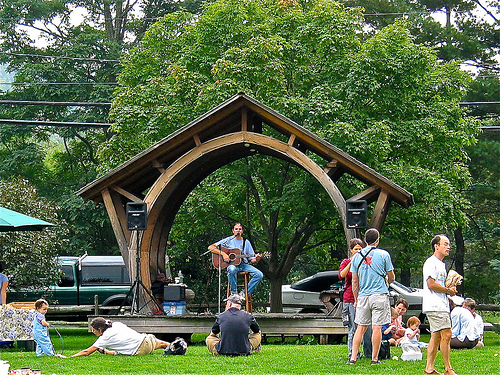<image>
Is the man on the stage? No. The man is not positioned on the stage. They may be near each other, but the man is not supported by or resting on top of the stage. Where is the guitar in relation to the tree? Is it in front of the tree? Yes. The guitar is positioned in front of the tree, appearing closer to the camera viewpoint. 